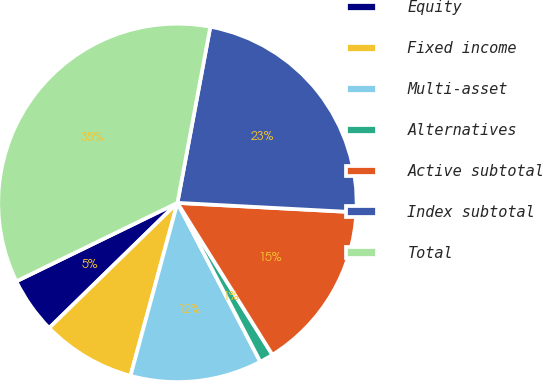<chart> <loc_0><loc_0><loc_500><loc_500><pie_chart><fcel>Equity<fcel>Fixed income<fcel>Multi-asset<fcel>Alternatives<fcel>Active subtotal<fcel>Index subtotal<fcel>Total<nl><fcel>5.09%<fcel>8.48%<fcel>11.87%<fcel>1.24%<fcel>15.27%<fcel>22.9%<fcel>35.15%<nl></chart> 